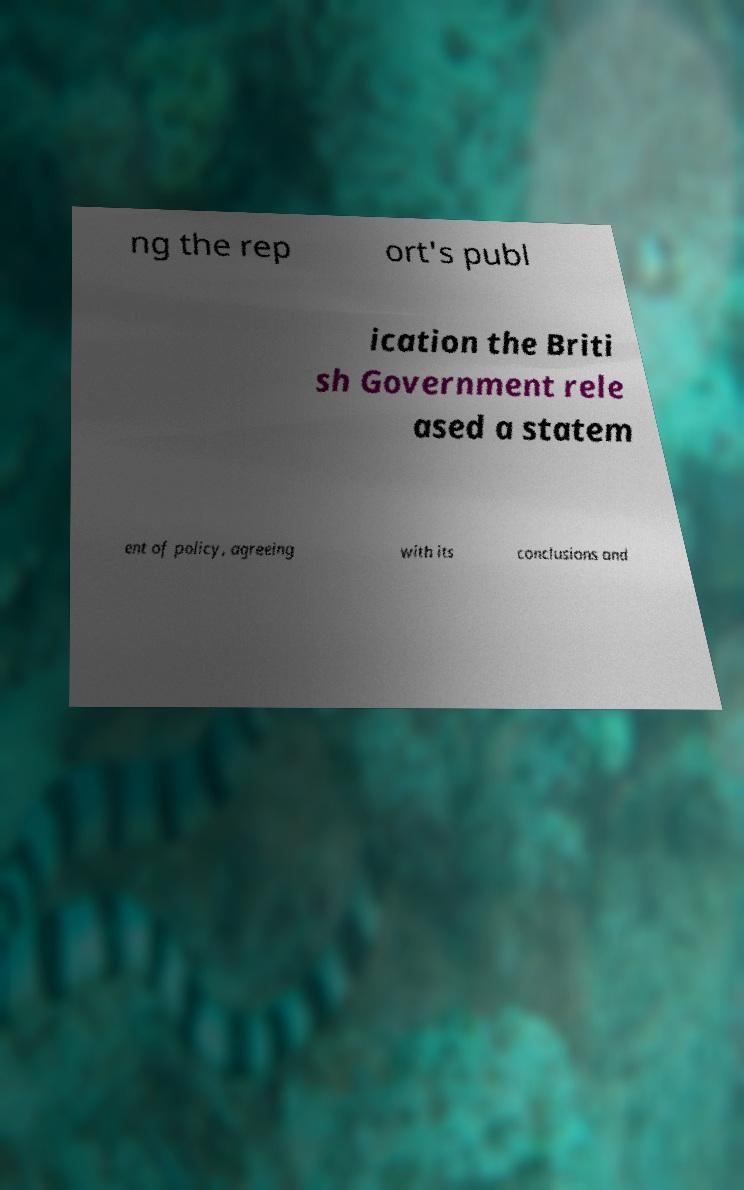Please identify and transcribe the text found in this image. ng the rep ort's publ ication the Briti sh Government rele ased a statem ent of policy, agreeing with its conclusions and 